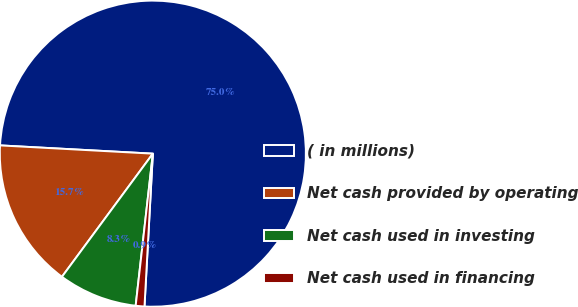Convert chart. <chart><loc_0><loc_0><loc_500><loc_500><pie_chart><fcel>( in millions)<fcel>Net cash provided by operating<fcel>Net cash used in investing<fcel>Net cash used in financing<nl><fcel>75.01%<fcel>15.74%<fcel>8.33%<fcel>0.92%<nl></chart> 